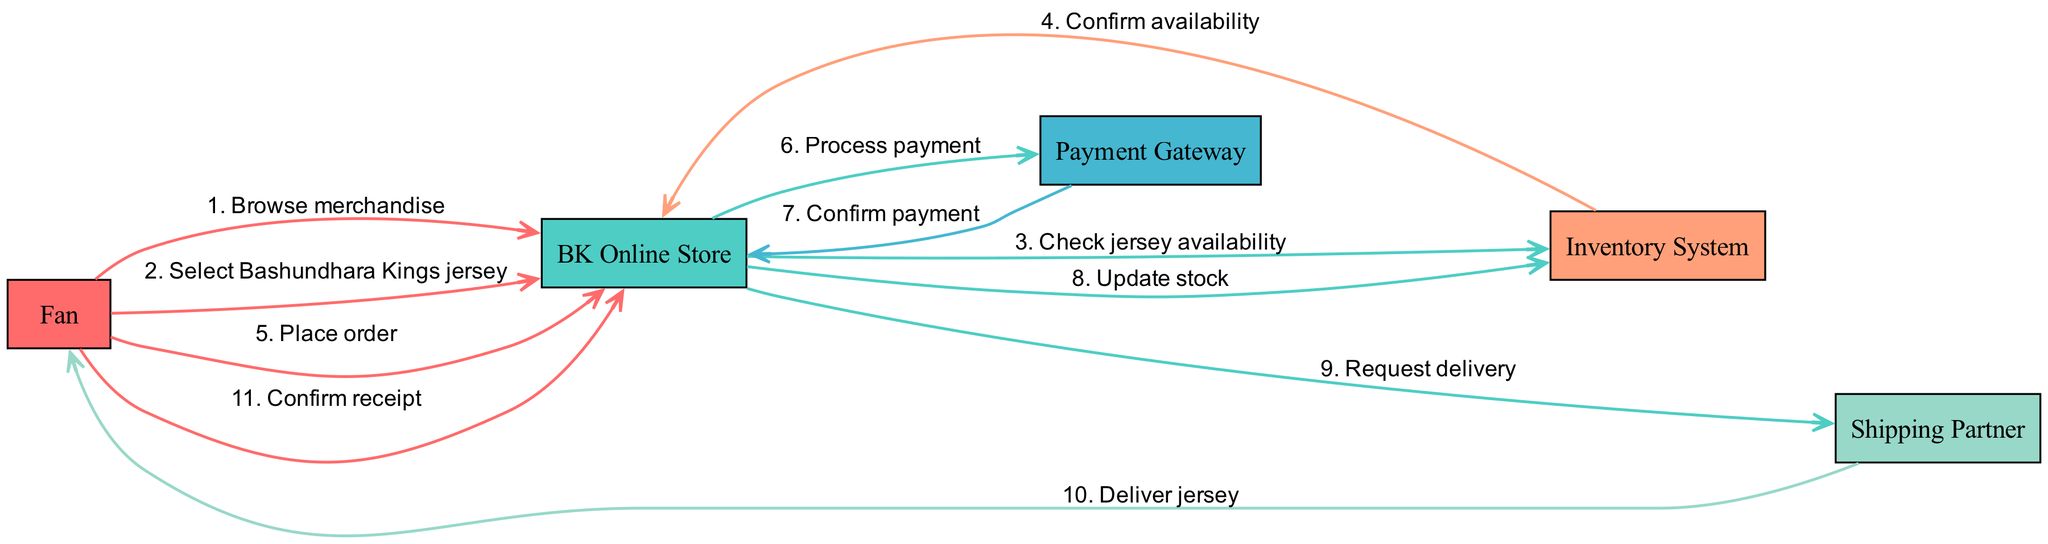What is the first action taken by the Fan? The diagram shows that the first action taken by the Fan is to "Browse merchandise." This action is the first message flowing from the Fan to the BK Online Store.
Answer: Browse merchandise How many nodes are present in the diagram? The diagram contains five unique nodes representing actors: Fan, BK Online Store, Payment Gateway, Inventory System, and Shipping Partner. Counting these gives us a total of five nodes.
Answer: 5 Who confirms the payment? According to the diagram, the Payment Gateway is responsible for confirming the payment after processing it. This is indicated by the message "Confirm payment" from the Payment Gateway back to the BK Online Store.
Answer: Payment Gateway What step follows the order placement by the Fan? After the Fan places the order, the next step is the BK Online Store processing the payment, as indicated by the message "Process payment" sent to the Payment Gateway.
Answer: Process payment What is the last interaction before the Fan confirms receipt? Before the Fan confirms receipt, the last interaction is the Shipping Partner delivering the jersey, which is indicated by the message "Deliver jersey" from the Shipping Partner to the Fan.
Answer: Deliver jersey Which actor updates the stock after payment confirmation? The BK Online Store updates the stock after receiving the payment confirmation from the Payment Gateway. This is indicated by the message "Update stock" sent from the BK Online Store to the Inventory System.
Answer: BK Online Store What is the primary purpose of the Inventory System in this process? The primary purpose of the Inventory System in the process is to confirm jersey availability and update stock levels after an order is placed. This dual role is reflected in the interactions with the BK Online Store during these steps.
Answer: Confirm availability and update stock How many messages are exchanged between the Fan and the BK Online Store? The diagram shows three distinct messages exchanged between the Fan and the BK Online Store: "Browse merchandise," "Select Bashundhara Kings jersey," and "Place order." Counting these gives us a total of three messages.
Answer: 3 What does the Shipping Partner deliver? The Shipping Partner delivers the jersey, as indicated by the message "Deliver jersey" flowing from the Shipping Partner to the Fan.
Answer: Jersey 